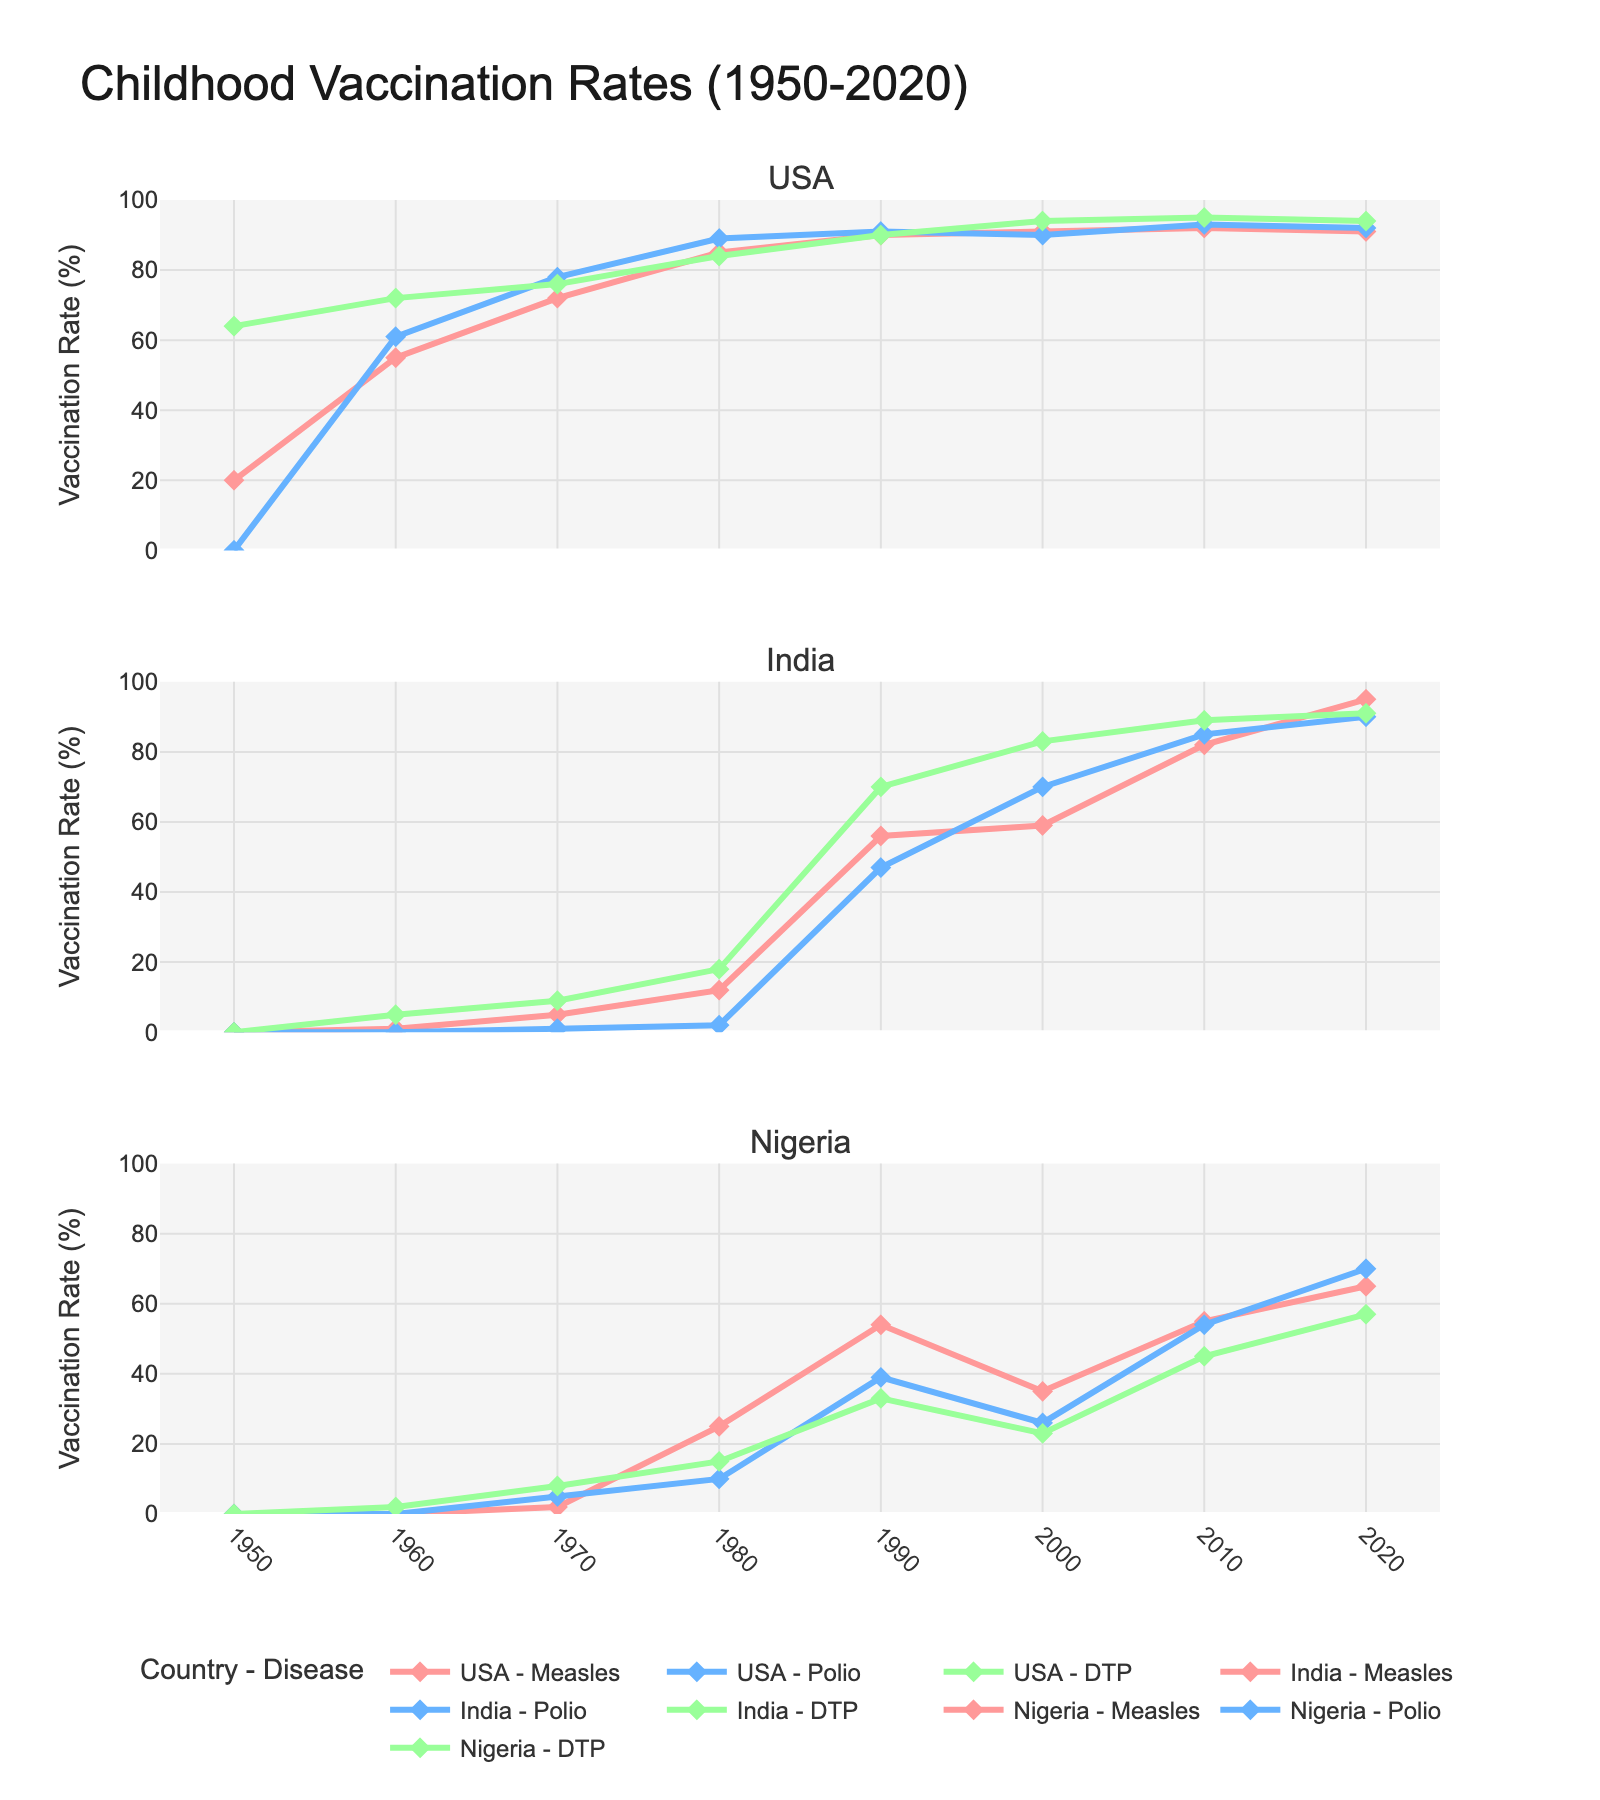Which country showed the highest increase in measles vaccination rates from 1950 to 2020? Examine the data for each country for measles vaccination rates in 1950 and 2020. The values are USA: 20% to 91%, India: 0% to 95%, and Nigeria: 0% to 65%. Calculate the increase: USA increased by 71%, India by 95%, and Nigeria by 65%.
Answer: India In which year did the USA achieve a 90% vaccination rate for DTP? Look at the USA's DTP vaccination rates over the years. The USA achieved a 90% vaccination rate for DTP in 1990.
Answer: 1990 Compare India and Nigeria's polio vaccination rates in 1990. Which country had a higher rate and by how much? Examine the data for India's and Nigeria's polio vaccination rates in 1990. India had a rate of 47%, and Nigeria had a rate of 39%. The difference is 47% - 39% = 8%.
Answer: India by 8% What was the average vaccination rate for Polio in the USA between 1950 and 2020? Sum the Polio vaccination rates for the USA from 1950 to 2020 and divide by the number of years listed (8 years). The rates are 0%, 61%, 78%, 89%, 91%, 90%, 93%, and 92%. The sum is 594%, and the average is 594% / 8 = 74.25%.
Answer: 74.25% In which decade did Nigeria see the biggest increase in DTP vaccination rates? Examine Nigeria's DTP vaccination rates at the beginning and end of each decade. The increases are 0% to 2% (1950-1960), 2% to 8% (1960-1970), 8% to 15% (1970-1980), 15% to 33% (1980-1990), 33% to 23% (1990-2000), 23% to 45% (2000-2010), and 45% to 57% (2010-2020). The largest increase was from 1980 to 1990 by 18%.
Answer: 1980-1990 How does the trend of measles vaccination rates in India compare to Nigeria from 1980 to 2020? Look at the data for measles vaccination rates in India and Nigeria for each decade from 1980 to 2020. India increased from 12% to 95%, while Nigeria increased from 25% to 65%. India shows a continuous sharp rise, whereas Nigeria shows a slower increase.
Answer: India increased faster than Nigeria What year did India surpass a 50% vaccination rate for measles? Look at India's measles vaccination rates over time. India surpassed a 50% rate for measles in 1990.
Answer: 1990 By how much did the DTP vaccination rate in the USA differ from the DTP vaccination rate in Nigeria in 2010? Check the DTP vaccination rates for the USA and Nigeria in 2010. USA is at 95%, and Nigeria is at 45%. The difference is 95% - 45% = 50%.
Answer: 50% 